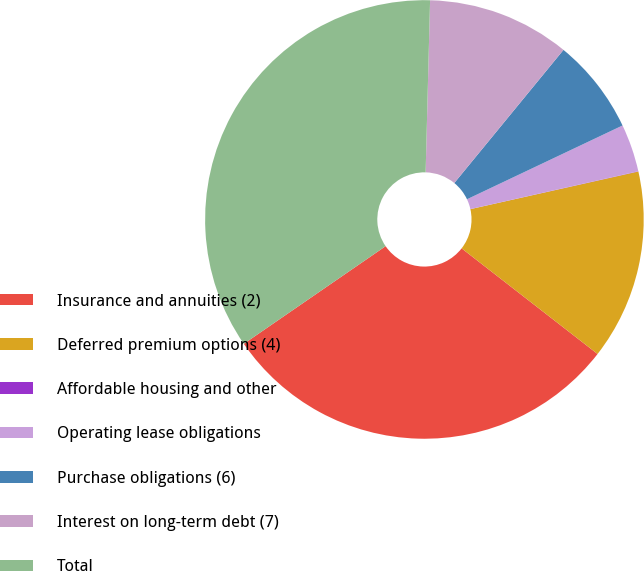<chart> <loc_0><loc_0><loc_500><loc_500><pie_chart><fcel>Insurance and annuities (2)<fcel>Deferred premium options (4)<fcel>Affordable housing and other<fcel>Operating lease obligations<fcel>Purchase obligations (6)<fcel>Interest on long-term debt (7)<fcel>Total<nl><fcel>29.89%<fcel>14.02%<fcel>0.02%<fcel>3.52%<fcel>7.02%<fcel>10.52%<fcel>35.01%<nl></chart> 